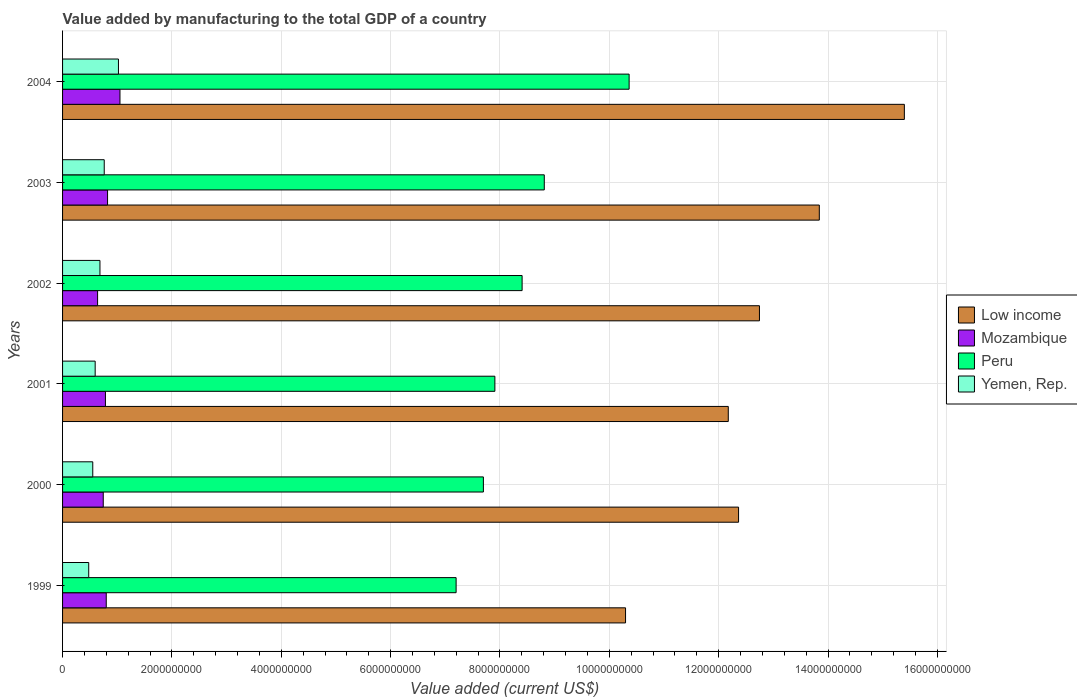How many different coloured bars are there?
Your answer should be compact. 4. Are the number of bars on each tick of the Y-axis equal?
Your response must be concise. Yes. How many bars are there on the 5th tick from the bottom?
Provide a succinct answer. 4. What is the value added by manufacturing to the total GDP in Yemen, Rep. in 1999?
Give a very brief answer. 4.78e+08. Across all years, what is the maximum value added by manufacturing to the total GDP in Yemen, Rep.?
Your answer should be very brief. 1.02e+09. Across all years, what is the minimum value added by manufacturing to the total GDP in Yemen, Rep.?
Provide a succinct answer. 4.78e+08. In which year was the value added by manufacturing to the total GDP in Yemen, Rep. maximum?
Provide a short and direct response. 2004. What is the total value added by manufacturing to the total GDP in Low income in the graph?
Your response must be concise. 7.68e+1. What is the difference between the value added by manufacturing to the total GDP in Mozambique in 2001 and that in 2002?
Provide a succinct answer. 1.43e+08. What is the difference between the value added by manufacturing to the total GDP in Yemen, Rep. in 2004 and the value added by manufacturing to the total GDP in Peru in 2002?
Your answer should be compact. -7.38e+09. What is the average value added by manufacturing to the total GDP in Low income per year?
Provide a succinct answer. 1.28e+1. In the year 2003, what is the difference between the value added by manufacturing to the total GDP in Low income and value added by manufacturing to the total GDP in Yemen, Rep.?
Offer a very short reply. 1.31e+1. What is the ratio of the value added by manufacturing to the total GDP in Yemen, Rep. in 2001 to that in 2002?
Your answer should be compact. 0.87. Is the value added by manufacturing to the total GDP in Yemen, Rep. in 2000 less than that in 2001?
Offer a very short reply. Yes. What is the difference between the highest and the second highest value added by manufacturing to the total GDP in Low income?
Provide a succinct answer. 1.56e+09. What is the difference between the highest and the lowest value added by manufacturing to the total GDP in Low income?
Keep it short and to the point. 5.10e+09. What does the 3rd bar from the top in 2003 represents?
Your response must be concise. Mozambique. What does the 4th bar from the bottom in 2004 represents?
Provide a short and direct response. Yemen, Rep. Is it the case that in every year, the sum of the value added by manufacturing to the total GDP in Mozambique and value added by manufacturing to the total GDP in Low income is greater than the value added by manufacturing to the total GDP in Peru?
Your response must be concise. Yes. How many bars are there?
Provide a short and direct response. 24. Are all the bars in the graph horizontal?
Ensure brevity in your answer.  Yes. How are the legend labels stacked?
Offer a very short reply. Vertical. What is the title of the graph?
Offer a very short reply. Value added by manufacturing to the total GDP of a country. What is the label or title of the X-axis?
Provide a short and direct response. Value added (current US$). What is the label or title of the Y-axis?
Ensure brevity in your answer.  Years. What is the Value added (current US$) of Low income in 1999?
Provide a succinct answer. 1.03e+1. What is the Value added (current US$) of Mozambique in 1999?
Ensure brevity in your answer.  7.99e+08. What is the Value added (current US$) in Peru in 1999?
Ensure brevity in your answer.  7.20e+09. What is the Value added (current US$) of Yemen, Rep. in 1999?
Your answer should be very brief. 4.78e+08. What is the Value added (current US$) in Low income in 2000?
Your answer should be very brief. 1.24e+1. What is the Value added (current US$) of Mozambique in 2000?
Provide a succinct answer. 7.44e+08. What is the Value added (current US$) of Peru in 2000?
Keep it short and to the point. 7.70e+09. What is the Value added (current US$) in Yemen, Rep. in 2000?
Your answer should be very brief. 5.52e+08. What is the Value added (current US$) of Low income in 2001?
Make the answer very short. 1.22e+1. What is the Value added (current US$) of Mozambique in 2001?
Make the answer very short. 7.84e+08. What is the Value added (current US$) in Peru in 2001?
Your answer should be compact. 7.91e+09. What is the Value added (current US$) of Yemen, Rep. in 2001?
Offer a terse response. 5.96e+08. What is the Value added (current US$) of Low income in 2002?
Give a very brief answer. 1.27e+1. What is the Value added (current US$) in Mozambique in 2002?
Provide a short and direct response. 6.41e+08. What is the Value added (current US$) of Peru in 2002?
Your response must be concise. 8.40e+09. What is the Value added (current US$) of Yemen, Rep. in 2002?
Your answer should be very brief. 6.84e+08. What is the Value added (current US$) in Low income in 2003?
Keep it short and to the point. 1.38e+1. What is the Value added (current US$) of Mozambique in 2003?
Ensure brevity in your answer.  8.23e+08. What is the Value added (current US$) in Peru in 2003?
Make the answer very short. 8.81e+09. What is the Value added (current US$) in Yemen, Rep. in 2003?
Provide a succinct answer. 7.62e+08. What is the Value added (current US$) in Low income in 2004?
Make the answer very short. 1.54e+1. What is the Value added (current US$) in Mozambique in 2004?
Offer a terse response. 1.05e+09. What is the Value added (current US$) in Peru in 2004?
Your answer should be very brief. 1.04e+1. What is the Value added (current US$) in Yemen, Rep. in 2004?
Provide a succinct answer. 1.02e+09. Across all years, what is the maximum Value added (current US$) in Low income?
Offer a terse response. 1.54e+1. Across all years, what is the maximum Value added (current US$) in Mozambique?
Provide a short and direct response. 1.05e+09. Across all years, what is the maximum Value added (current US$) of Peru?
Your response must be concise. 1.04e+1. Across all years, what is the maximum Value added (current US$) in Yemen, Rep.?
Offer a terse response. 1.02e+09. Across all years, what is the minimum Value added (current US$) of Low income?
Your answer should be compact. 1.03e+1. Across all years, what is the minimum Value added (current US$) in Mozambique?
Make the answer very short. 6.41e+08. Across all years, what is the minimum Value added (current US$) of Peru?
Your response must be concise. 7.20e+09. Across all years, what is the minimum Value added (current US$) in Yemen, Rep.?
Ensure brevity in your answer.  4.78e+08. What is the total Value added (current US$) in Low income in the graph?
Your answer should be compact. 7.68e+1. What is the total Value added (current US$) in Mozambique in the graph?
Your response must be concise. 4.84e+09. What is the total Value added (current US$) in Peru in the graph?
Provide a succinct answer. 5.04e+1. What is the total Value added (current US$) of Yemen, Rep. in the graph?
Give a very brief answer. 4.09e+09. What is the difference between the Value added (current US$) of Low income in 1999 and that in 2000?
Keep it short and to the point. -2.07e+09. What is the difference between the Value added (current US$) of Mozambique in 1999 and that in 2000?
Your answer should be compact. 5.49e+07. What is the difference between the Value added (current US$) in Peru in 1999 and that in 2000?
Offer a very short reply. -4.99e+08. What is the difference between the Value added (current US$) in Yemen, Rep. in 1999 and that in 2000?
Your answer should be very brief. -7.40e+07. What is the difference between the Value added (current US$) of Low income in 1999 and that in 2001?
Provide a short and direct response. -1.88e+09. What is the difference between the Value added (current US$) of Mozambique in 1999 and that in 2001?
Keep it short and to the point. 1.49e+07. What is the difference between the Value added (current US$) in Peru in 1999 and that in 2001?
Ensure brevity in your answer.  -7.09e+08. What is the difference between the Value added (current US$) in Yemen, Rep. in 1999 and that in 2001?
Provide a short and direct response. -1.18e+08. What is the difference between the Value added (current US$) in Low income in 1999 and that in 2002?
Your answer should be compact. -2.45e+09. What is the difference between the Value added (current US$) of Mozambique in 1999 and that in 2002?
Give a very brief answer. 1.58e+08. What is the difference between the Value added (current US$) of Peru in 1999 and that in 2002?
Offer a very short reply. -1.21e+09. What is the difference between the Value added (current US$) of Yemen, Rep. in 1999 and that in 2002?
Provide a succinct answer. -2.05e+08. What is the difference between the Value added (current US$) of Low income in 1999 and that in 2003?
Provide a succinct answer. -3.54e+09. What is the difference between the Value added (current US$) in Mozambique in 1999 and that in 2003?
Your answer should be compact. -2.40e+07. What is the difference between the Value added (current US$) of Peru in 1999 and that in 2003?
Offer a terse response. -1.61e+09. What is the difference between the Value added (current US$) of Yemen, Rep. in 1999 and that in 2003?
Offer a very short reply. -2.84e+08. What is the difference between the Value added (current US$) in Low income in 1999 and that in 2004?
Your answer should be compact. -5.10e+09. What is the difference between the Value added (current US$) in Mozambique in 1999 and that in 2004?
Provide a short and direct response. -2.51e+08. What is the difference between the Value added (current US$) of Peru in 1999 and that in 2004?
Keep it short and to the point. -3.16e+09. What is the difference between the Value added (current US$) of Yemen, Rep. in 1999 and that in 2004?
Keep it short and to the point. -5.44e+08. What is the difference between the Value added (current US$) in Low income in 2000 and that in 2001?
Offer a terse response. 1.88e+08. What is the difference between the Value added (current US$) of Mozambique in 2000 and that in 2001?
Keep it short and to the point. -4.00e+07. What is the difference between the Value added (current US$) of Peru in 2000 and that in 2001?
Ensure brevity in your answer.  -2.10e+08. What is the difference between the Value added (current US$) in Yemen, Rep. in 2000 and that in 2001?
Ensure brevity in your answer.  -4.41e+07. What is the difference between the Value added (current US$) of Low income in 2000 and that in 2002?
Offer a terse response. -3.82e+08. What is the difference between the Value added (current US$) in Mozambique in 2000 and that in 2002?
Ensure brevity in your answer.  1.03e+08. What is the difference between the Value added (current US$) of Peru in 2000 and that in 2002?
Your answer should be compact. -7.08e+08. What is the difference between the Value added (current US$) of Yemen, Rep. in 2000 and that in 2002?
Provide a succinct answer. -1.31e+08. What is the difference between the Value added (current US$) of Low income in 2000 and that in 2003?
Your answer should be compact. -1.48e+09. What is the difference between the Value added (current US$) of Mozambique in 2000 and that in 2003?
Your answer should be very brief. -7.89e+07. What is the difference between the Value added (current US$) of Peru in 2000 and that in 2003?
Give a very brief answer. -1.11e+09. What is the difference between the Value added (current US$) in Yemen, Rep. in 2000 and that in 2003?
Offer a terse response. -2.10e+08. What is the difference between the Value added (current US$) of Low income in 2000 and that in 2004?
Offer a terse response. -3.03e+09. What is the difference between the Value added (current US$) of Mozambique in 2000 and that in 2004?
Offer a terse response. -3.06e+08. What is the difference between the Value added (current US$) of Peru in 2000 and that in 2004?
Offer a terse response. -2.67e+09. What is the difference between the Value added (current US$) of Yemen, Rep. in 2000 and that in 2004?
Ensure brevity in your answer.  -4.70e+08. What is the difference between the Value added (current US$) in Low income in 2001 and that in 2002?
Keep it short and to the point. -5.70e+08. What is the difference between the Value added (current US$) in Mozambique in 2001 and that in 2002?
Offer a terse response. 1.43e+08. What is the difference between the Value added (current US$) of Peru in 2001 and that in 2002?
Your answer should be very brief. -4.98e+08. What is the difference between the Value added (current US$) of Yemen, Rep. in 2001 and that in 2002?
Offer a terse response. -8.73e+07. What is the difference between the Value added (current US$) in Low income in 2001 and that in 2003?
Provide a short and direct response. -1.66e+09. What is the difference between the Value added (current US$) in Mozambique in 2001 and that in 2003?
Provide a short and direct response. -3.89e+07. What is the difference between the Value added (current US$) in Peru in 2001 and that in 2003?
Keep it short and to the point. -9.04e+08. What is the difference between the Value added (current US$) in Yemen, Rep. in 2001 and that in 2003?
Your response must be concise. -1.66e+08. What is the difference between the Value added (current US$) in Low income in 2001 and that in 2004?
Your response must be concise. -3.22e+09. What is the difference between the Value added (current US$) in Mozambique in 2001 and that in 2004?
Offer a terse response. -2.66e+08. What is the difference between the Value added (current US$) in Peru in 2001 and that in 2004?
Offer a very short reply. -2.46e+09. What is the difference between the Value added (current US$) of Yemen, Rep. in 2001 and that in 2004?
Provide a short and direct response. -4.26e+08. What is the difference between the Value added (current US$) in Low income in 2002 and that in 2003?
Provide a short and direct response. -1.09e+09. What is the difference between the Value added (current US$) of Mozambique in 2002 and that in 2003?
Your answer should be compact. -1.82e+08. What is the difference between the Value added (current US$) in Peru in 2002 and that in 2003?
Keep it short and to the point. -4.06e+08. What is the difference between the Value added (current US$) in Yemen, Rep. in 2002 and that in 2003?
Your answer should be compact. -7.83e+07. What is the difference between the Value added (current US$) of Low income in 2002 and that in 2004?
Give a very brief answer. -2.65e+09. What is the difference between the Value added (current US$) in Mozambique in 2002 and that in 2004?
Ensure brevity in your answer.  -4.09e+08. What is the difference between the Value added (current US$) of Peru in 2002 and that in 2004?
Give a very brief answer. -1.96e+09. What is the difference between the Value added (current US$) of Yemen, Rep. in 2002 and that in 2004?
Your answer should be very brief. -3.38e+08. What is the difference between the Value added (current US$) of Low income in 2003 and that in 2004?
Keep it short and to the point. -1.56e+09. What is the difference between the Value added (current US$) in Mozambique in 2003 and that in 2004?
Keep it short and to the point. -2.27e+08. What is the difference between the Value added (current US$) of Peru in 2003 and that in 2004?
Keep it short and to the point. -1.55e+09. What is the difference between the Value added (current US$) of Yemen, Rep. in 2003 and that in 2004?
Provide a succinct answer. -2.60e+08. What is the difference between the Value added (current US$) of Low income in 1999 and the Value added (current US$) of Mozambique in 2000?
Offer a terse response. 9.55e+09. What is the difference between the Value added (current US$) of Low income in 1999 and the Value added (current US$) of Peru in 2000?
Your response must be concise. 2.60e+09. What is the difference between the Value added (current US$) in Low income in 1999 and the Value added (current US$) in Yemen, Rep. in 2000?
Your answer should be very brief. 9.74e+09. What is the difference between the Value added (current US$) of Mozambique in 1999 and the Value added (current US$) of Peru in 2000?
Provide a succinct answer. -6.90e+09. What is the difference between the Value added (current US$) in Mozambique in 1999 and the Value added (current US$) in Yemen, Rep. in 2000?
Keep it short and to the point. 2.47e+08. What is the difference between the Value added (current US$) in Peru in 1999 and the Value added (current US$) in Yemen, Rep. in 2000?
Ensure brevity in your answer.  6.65e+09. What is the difference between the Value added (current US$) of Low income in 1999 and the Value added (current US$) of Mozambique in 2001?
Offer a very short reply. 9.51e+09. What is the difference between the Value added (current US$) of Low income in 1999 and the Value added (current US$) of Peru in 2001?
Provide a succinct answer. 2.39e+09. What is the difference between the Value added (current US$) in Low income in 1999 and the Value added (current US$) in Yemen, Rep. in 2001?
Keep it short and to the point. 9.70e+09. What is the difference between the Value added (current US$) in Mozambique in 1999 and the Value added (current US$) in Peru in 2001?
Keep it short and to the point. -7.11e+09. What is the difference between the Value added (current US$) of Mozambique in 1999 and the Value added (current US$) of Yemen, Rep. in 2001?
Ensure brevity in your answer.  2.03e+08. What is the difference between the Value added (current US$) of Peru in 1999 and the Value added (current US$) of Yemen, Rep. in 2001?
Provide a succinct answer. 6.60e+09. What is the difference between the Value added (current US$) of Low income in 1999 and the Value added (current US$) of Mozambique in 2002?
Your answer should be compact. 9.66e+09. What is the difference between the Value added (current US$) in Low income in 1999 and the Value added (current US$) in Peru in 2002?
Provide a short and direct response. 1.89e+09. What is the difference between the Value added (current US$) in Low income in 1999 and the Value added (current US$) in Yemen, Rep. in 2002?
Your answer should be very brief. 9.61e+09. What is the difference between the Value added (current US$) in Mozambique in 1999 and the Value added (current US$) in Peru in 2002?
Give a very brief answer. -7.61e+09. What is the difference between the Value added (current US$) of Mozambique in 1999 and the Value added (current US$) of Yemen, Rep. in 2002?
Give a very brief answer. 1.15e+08. What is the difference between the Value added (current US$) in Peru in 1999 and the Value added (current US$) in Yemen, Rep. in 2002?
Make the answer very short. 6.51e+09. What is the difference between the Value added (current US$) of Low income in 1999 and the Value added (current US$) of Mozambique in 2003?
Offer a very short reply. 9.47e+09. What is the difference between the Value added (current US$) in Low income in 1999 and the Value added (current US$) in Peru in 2003?
Make the answer very short. 1.49e+09. What is the difference between the Value added (current US$) in Low income in 1999 and the Value added (current US$) in Yemen, Rep. in 2003?
Keep it short and to the point. 9.53e+09. What is the difference between the Value added (current US$) in Mozambique in 1999 and the Value added (current US$) in Peru in 2003?
Your answer should be compact. -8.01e+09. What is the difference between the Value added (current US$) of Mozambique in 1999 and the Value added (current US$) of Yemen, Rep. in 2003?
Provide a short and direct response. 3.70e+07. What is the difference between the Value added (current US$) in Peru in 1999 and the Value added (current US$) in Yemen, Rep. in 2003?
Give a very brief answer. 6.44e+09. What is the difference between the Value added (current US$) in Low income in 1999 and the Value added (current US$) in Mozambique in 2004?
Your answer should be very brief. 9.25e+09. What is the difference between the Value added (current US$) in Low income in 1999 and the Value added (current US$) in Peru in 2004?
Your response must be concise. -6.55e+07. What is the difference between the Value added (current US$) of Low income in 1999 and the Value added (current US$) of Yemen, Rep. in 2004?
Keep it short and to the point. 9.27e+09. What is the difference between the Value added (current US$) in Mozambique in 1999 and the Value added (current US$) in Peru in 2004?
Provide a short and direct response. -9.56e+09. What is the difference between the Value added (current US$) in Mozambique in 1999 and the Value added (current US$) in Yemen, Rep. in 2004?
Give a very brief answer. -2.23e+08. What is the difference between the Value added (current US$) of Peru in 1999 and the Value added (current US$) of Yemen, Rep. in 2004?
Your answer should be very brief. 6.18e+09. What is the difference between the Value added (current US$) of Low income in 2000 and the Value added (current US$) of Mozambique in 2001?
Your response must be concise. 1.16e+1. What is the difference between the Value added (current US$) of Low income in 2000 and the Value added (current US$) of Peru in 2001?
Your response must be concise. 4.46e+09. What is the difference between the Value added (current US$) in Low income in 2000 and the Value added (current US$) in Yemen, Rep. in 2001?
Keep it short and to the point. 1.18e+1. What is the difference between the Value added (current US$) in Mozambique in 2000 and the Value added (current US$) in Peru in 2001?
Provide a short and direct response. -7.16e+09. What is the difference between the Value added (current US$) of Mozambique in 2000 and the Value added (current US$) of Yemen, Rep. in 2001?
Ensure brevity in your answer.  1.48e+08. What is the difference between the Value added (current US$) in Peru in 2000 and the Value added (current US$) in Yemen, Rep. in 2001?
Provide a short and direct response. 7.10e+09. What is the difference between the Value added (current US$) in Low income in 2000 and the Value added (current US$) in Mozambique in 2002?
Ensure brevity in your answer.  1.17e+1. What is the difference between the Value added (current US$) in Low income in 2000 and the Value added (current US$) in Peru in 2002?
Provide a succinct answer. 3.96e+09. What is the difference between the Value added (current US$) in Low income in 2000 and the Value added (current US$) in Yemen, Rep. in 2002?
Offer a very short reply. 1.17e+1. What is the difference between the Value added (current US$) of Mozambique in 2000 and the Value added (current US$) of Peru in 2002?
Your answer should be compact. -7.66e+09. What is the difference between the Value added (current US$) in Mozambique in 2000 and the Value added (current US$) in Yemen, Rep. in 2002?
Your answer should be very brief. 6.04e+07. What is the difference between the Value added (current US$) in Peru in 2000 and the Value added (current US$) in Yemen, Rep. in 2002?
Ensure brevity in your answer.  7.01e+09. What is the difference between the Value added (current US$) of Low income in 2000 and the Value added (current US$) of Mozambique in 2003?
Keep it short and to the point. 1.15e+1. What is the difference between the Value added (current US$) of Low income in 2000 and the Value added (current US$) of Peru in 2003?
Your answer should be compact. 3.55e+09. What is the difference between the Value added (current US$) of Low income in 2000 and the Value added (current US$) of Yemen, Rep. in 2003?
Your answer should be very brief. 1.16e+1. What is the difference between the Value added (current US$) in Mozambique in 2000 and the Value added (current US$) in Peru in 2003?
Your response must be concise. -8.07e+09. What is the difference between the Value added (current US$) in Mozambique in 2000 and the Value added (current US$) in Yemen, Rep. in 2003?
Your response must be concise. -1.79e+07. What is the difference between the Value added (current US$) in Peru in 2000 and the Value added (current US$) in Yemen, Rep. in 2003?
Your answer should be compact. 6.93e+09. What is the difference between the Value added (current US$) in Low income in 2000 and the Value added (current US$) in Mozambique in 2004?
Provide a short and direct response. 1.13e+1. What is the difference between the Value added (current US$) in Low income in 2000 and the Value added (current US$) in Peru in 2004?
Your answer should be compact. 2.00e+09. What is the difference between the Value added (current US$) in Low income in 2000 and the Value added (current US$) in Yemen, Rep. in 2004?
Make the answer very short. 1.13e+1. What is the difference between the Value added (current US$) in Mozambique in 2000 and the Value added (current US$) in Peru in 2004?
Your answer should be compact. -9.62e+09. What is the difference between the Value added (current US$) of Mozambique in 2000 and the Value added (current US$) of Yemen, Rep. in 2004?
Make the answer very short. -2.78e+08. What is the difference between the Value added (current US$) of Peru in 2000 and the Value added (current US$) of Yemen, Rep. in 2004?
Your response must be concise. 6.67e+09. What is the difference between the Value added (current US$) in Low income in 2001 and the Value added (current US$) in Mozambique in 2002?
Keep it short and to the point. 1.15e+1. What is the difference between the Value added (current US$) of Low income in 2001 and the Value added (current US$) of Peru in 2002?
Offer a very short reply. 3.77e+09. What is the difference between the Value added (current US$) in Low income in 2001 and the Value added (current US$) in Yemen, Rep. in 2002?
Your answer should be very brief. 1.15e+1. What is the difference between the Value added (current US$) of Mozambique in 2001 and the Value added (current US$) of Peru in 2002?
Offer a terse response. -7.62e+09. What is the difference between the Value added (current US$) in Mozambique in 2001 and the Value added (current US$) in Yemen, Rep. in 2002?
Your response must be concise. 1.00e+08. What is the difference between the Value added (current US$) of Peru in 2001 and the Value added (current US$) of Yemen, Rep. in 2002?
Keep it short and to the point. 7.22e+09. What is the difference between the Value added (current US$) in Low income in 2001 and the Value added (current US$) in Mozambique in 2003?
Your response must be concise. 1.14e+1. What is the difference between the Value added (current US$) of Low income in 2001 and the Value added (current US$) of Peru in 2003?
Provide a succinct answer. 3.37e+09. What is the difference between the Value added (current US$) in Low income in 2001 and the Value added (current US$) in Yemen, Rep. in 2003?
Offer a very short reply. 1.14e+1. What is the difference between the Value added (current US$) in Mozambique in 2001 and the Value added (current US$) in Peru in 2003?
Provide a succinct answer. -8.03e+09. What is the difference between the Value added (current US$) of Mozambique in 2001 and the Value added (current US$) of Yemen, Rep. in 2003?
Provide a succinct answer. 2.21e+07. What is the difference between the Value added (current US$) in Peru in 2001 and the Value added (current US$) in Yemen, Rep. in 2003?
Your response must be concise. 7.14e+09. What is the difference between the Value added (current US$) in Low income in 2001 and the Value added (current US$) in Mozambique in 2004?
Provide a succinct answer. 1.11e+1. What is the difference between the Value added (current US$) in Low income in 2001 and the Value added (current US$) in Peru in 2004?
Provide a short and direct response. 1.81e+09. What is the difference between the Value added (current US$) of Low income in 2001 and the Value added (current US$) of Yemen, Rep. in 2004?
Keep it short and to the point. 1.12e+1. What is the difference between the Value added (current US$) in Mozambique in 2001 and the Value added (current US$) in Peru in 2004?
Your response must be concise. -9.58e+09. What is the difference between the Value added (current US$) in Mozambique in 2001 and the Value added (current US$) in Yemen, Rep. in 2004?
Offer a very short reply. -2.38e+08. What is the difference between the Value added (current US$) in Peru in 2001 and the Value added (current US$) in Yemen, Rep. in 2004?
Give a very brief answer. 6.88e+09. What is the difference between the Value added (current US$) in Low income in 2002 and the Value added (current US$) in Mozambique in 2003?
Offer a very short reply. 1.19e+1. What is the difference between the Value added (current US$) of Low income in 2002 and the Value added (current US$) of Peru in 2003?
Keep it short and to the point. 3.94e+09. What is the difference between the Value added (current US$) in Low income in 2002 and the Value added (current US$) in Yemen, Rep. in 2003?
Your response must be concise. 1.20e+1. What is the difference between the Value added (current US$) in Mozambique in 2002 and the Value added (current US$) in Peru in 2003?
Offer a very short reply. -8.17e+09. What is the difference between the Value added (current US$) of Mozambique in 2002 and the Value added (current US$) of Yemen, Rep. in 2003?
Make the answer very short. -1.21e+08. What is the difference between the Value added (current US$) in Peru in 2002 and the Value added (current US$) in Yemen, Rep. in 2003?
Ensure brevity in your answer.  7.64e+09. What is the difference between the Value added (current US$) of Low income in 2002 and the Value added (current US$) of Mozambique in 2004?
Give a very brief answer. 1.17e+1. What is the difference between the Value added (current US$) of Low income in 2002 and the Value added (current US$) of Peru in 2004?
Your answer should be compact. 2.38e+09. What is the difference between the Value added (current US$) in Low income in 2002 and the Value added (current US$) in Yemen, Rep. in 2004?
Offer a terse response. 1.17e+1. What is the difference between the Value added (current US$) of Mozambique in 2002 and the Value added (current US$) of Peru in 2004?
Ensure brevity in your answer.  -9.72e+09. What is the difference between the Value added (current US$) in Mozambique in 2002 and the Value added (current US$) in Yemen, Rep. in 2004?
Your response must be concise. -3.81e+08. What is the difference between the Value added (current US$) in Peru in 2002 and the Value added (current US$) in Yemen, Rep. in 2004?
Your response must be concise. 7.38e+09. What is the difference between the Value added (current US$) in Low income in 2003 and the Value added (current US$) in Mozambique in 2004?
Offer a very short reply. 1.28e+1. What is the difference between the Value added (current US$) of Low income in 2003 and the Value added (current US$) of Peru in 2004?
Your answer should be compact. 3.48e+09. What is the difference between the Value added (current US$) in Low income in 2003 and the Value added (current US$) in Yemen, Rep. in 2004?
Ensure brevity in your answer.  1.28e+1. What is the difference between the Value added (current US$) of Mozambique in 2003 and the Value added (current US$) of Peru in 2004?
Offer a terse response. -9.54e+09. What is the difference between the Value added (current US$) in Mozambique in 2003 and the Value added (current US$) in Yemen, Rep. in 2004?
Give a very brief answer. -1.99e+08. What is the difference between the Value added (current US$) of Peru in 2003 and the Value added (current US$) of Yemen, Rep. in 2004?
Keep it short and to the point. 7.79e+09. What is the average Value added (current US$) in Low income per year?
Make the answer very short. 1.28e+1. What is the average Value added (current US$) in Mozambique per year?
Give a very brief answer. 8.07e+08. What is the average Value added (current US$) in Peru per year?
Keep it short and to the point. 8.40e+09. What is the average Value added (current US$) in Yemen, Rep. per year?
Make the answer very short. 6.82e+08. In the year 1999, what is the difference between the Value added (current US$) in Low income and Value added (current US$) in Mozambique?
Your answer should be compact. 9.50e+09. In the year 1999, what is the difference between the Value added (current US$) in Low income and Value added (current US$) in Peru?
Ensure brevity in your answer.  3.10e+09. In the year 1999, what is the difference between the Value added (current US$) in Low income and Value added (current US$) in Yemen, Rep.?
Offer a terse response. 9.82e+09. In the year 1999, what is the difference between the Value added (current US$) of Mozambique and Value added (current US$) of Peru?
Make the answer very short. -6.40e+09. In the year 1999, what is the difference between the Value added (current US$) in Mozambique and Value added (current US$) in Yemen, Rep.?
Your answer should be compact. 3.21e+08. In the year 1999, what is the difference between the Value added (current US$) in Peru and Value added (current US$) in Yemen, Rep.?
Make the answer very short. 6.72e+09. In the year 2000, what is the difference between the Value added (current US$) in Low income and Value added (current US$) in Mozambique?
Provide a short and direct response. 1.16e+1. In the year 2000, what is the difference between the Value added (current US$) of Low income and Value added (current US$) of Peru?
Offer a very short reply. 4.67e+09. In the year 2000, what is the difference between the Value added (current US$) in Low income and Value added (current US$) in Yemen, Rep.?
Make the answer very short. 1.18e+1. In the year 2000, what is the difference between the Value added (current US$) in Mozambique and Value added (current US$) in Peru?
Your answer should be compact. -6.95e+09. In the year 2000, what is the difference between the Value added (current US$) in Mozambique and Value added (current US$) in Yemen, Rep.?
Offer a terse response. 1.92e+08. In the year 2000, what is the difference between the Value added (current US$) of Peru and Value added (current US$) of Yemen, Rep.?
Give a very brief answer. 7.14e+09. In the year 2001, what is the difference between the Value added (current US$) of Low income and Value added (current US$) of Mozambique?
Give a very brief answer. 1.14e+1. In the year 2001, what is the difference between the Value added (current US$) of Low income and Value added (current US$) of Peru?
Offer a terse response. 4.27e+09. In the year 2001, what is the difference between the Value added (current US$) in Low income and Value added (current US$) in Yemen, Rep.?
Give a very brief answer. 1.16e+1. In the year 2001, what is the difference between the Value added (current US$) in Mozambique and Value added (current US$) in Peru?
Offer a very short reply. -7.12e+09. In the year 2001, what is the difference between the Value added (current US$) of Mozambique and Value added (current US$) of Yemen, Rep.?
Give a very brief answer. 1.88e+08. In the year 2001, what is the difference between the Value added (current US$) of Peru and Value added (current US$) of Yemen, Rep.?
Your answer should be very brief. 7.31e+09. In the year 2002, what is the difference between the Value added (current US$) in Low income and Value added (current US$) in Mozambique?
Ensure brevity in your answer.  1.21e+1. In the year 2002, what is the difference between the Value added (current US$) in Low income and Value added (current US$) in Peru?
Your answer should be very brief. 4.34e+09. In the year 2002, what is the difference between the Value added (current US$) in Low income and Value added (current US$) in Yemen, Rep.?
Your answer should be very brief. 1.21e+1. In the year 2002, what is the difference between the Value added (current US$) of Mozambique and Value added (current US$) of Peru?
Your response must be concise. -7.76e+09. In the year 2002, what is the difference between the Value added (current US$) of Mozambique and Value added (current US$) of Yemen, Rep.?
Your response must be concise. -4.29e+07. In the year 2002, what is the difference between the Value added (current US$) in Peru and Value added (current US$) in Yemen, Rep.?
Give a very brief answer. 7.72e+09. In the year 2003, what is the difference between the Value added (current US$) in Low income and Value added (current US$) in Mozambique?
Ensure brevity in your answer.  1.30e+1. In the year 2003, what is the difference between the Value added (current US$) of Low income and Value added (current US$) of Peru?
Ensure brevity in your answer.  5.03e+09. In the year 2003, what is the difference between the Value added (current US$) of Low income and Value added (current US$) of Yemen, Rep.?
Your answer should be compact. 1.31e+1. In the year 2003, what is the difference between the Value added (current US$) in Mozambique and Value added (current US$) in Peru?
Your answer should be compact. -7.99e+09. In the year 2003, what is the difference between the Value added (current US$) of Mozambique and Value added (current US$) of Yemen, Rep.?
Your response must be concise. 6.10e+07. In the year 2003, what is the difference between the Value added (current US$) in Peru and Value added (current US$) in Yemen, Rep.?
Provide a succinct answer. 8.05e+09. In the year 2004, what is the difference between the Value added (current US$) in Low income and Value added (current US$) in Mozambique?
Your answer should be very brief. 1.43e+1. In the year 2004, what is the difference between the Value added (current US$) of Low income and Value added (current US$) of Peru?
Your answer should be very brief. 5.03e+09. In the year 2004, what is the difference between the Value added (current US$) in Low income and Value added (current US$) in Yemen, Rep.?
Give a very brief answer. 1.44e+1. In the year 2004, what is the difference between the Value added (current US$) of Mozambique and Value added (current US$) of Peru?
Your response must be concise. -9.31e+09. In the year 2004, what is the difference between the Value added (current US$) in Mozambique and Value added (current US$) in Yemen, Rep.?
Make the answer very short. 2.77e+07. In the year 2004, what is the difference between the Value added (current US$) in Peru and Value added (current US$) in Yemen, Rep.?
Give a very brief answer. 9.34e+09. What is the ratio of the Value added (current US$) in Low income in 1999 to that in 2000?
Your response must be concise. 0.83. What is the ratio of the Value added (current US$) of Mozambique in 1999 to that in 2000?
Make the answer very short. 1.07. What is the ratio of the Value added (current US$) in Peru in 1999 to that in 2000?
Offer a terse response. 0.94. What is the ratio of the Value added (current US$) in Yemen, Rep. in 1999 to that in 2000?
Provide a succinct answer. 0.87. What is the ratio of the Value added (current US$) of Low income in 1999 to that in 2001?
Give a very brief answer. 0.85. What is the ratio of the Value added (current US$) in Peru in 1999 to that in 2001?
Make the answer very short. 0.91. What is the ratio of the Value added (current US$) in Yemen, Rep. in 1999 to that in 2001?
Offer a terse response. 0.8. What is the ratio of the Value added (current US$) in Low income in 1999 to that in 2002?
Keep it short and to the point. 0.81. What is the ratio of the Value added (current US$) of Mozambique in 1999 to that in 2002?
Provide a succinct answer. 1.25. What is the ratio of the Value added (current US$) of Peru in 1999 to that in 2002?
Keep it short and to the point. 0.86. What is the ratio of the Value added (current US$) of Yemen, Rep. in 1999 to that in 2002?
Offer a very short reply. 0.7. What is the ratio of the Value added (current US$) in Low income in 1999 to that in 2003?
Your response must be concise. 0.74. What is the ratio of the Value added (current US$) in Mozambique in 1999 to that in 2003?
Your answer should be compact. 0.97. What is the ratio of the Value added (current US$) in Peru in 1999 to that in 2003?
Offer a terse response. 0.82. What is the ratio of the Value added (current US$) in Yemen, Rep. in 1999 to that in 2003?
Keep it short and to the point. 0.63. What is the ratio of the Value added (current US$) of Low income in 1999 to that in 2004?
Give a very brief answer. 0.67. What is the ratio of the Value added (current US$) in Mozambique in 1999 to that in 2004?
Provide a succinct answer. 0.76. What is the ratio of the Value added (current US$) in Peru in 1999 to that in 2004?
Your answer should be compact. 0.69. What is the ratio of the Value added (current US$) in Yemen, Rep. in 1999 to that in 2004?
Your answer should be very brief. 0.47. What is the ratio of the Value added (current US$) of Low income in 2000 to that in 2001?
Provide a succinct answer. 1.02. What is the ratio of the Value added (current US$) of Mozambique in 2000 to that in 2001?
Your response must be concise. 0.95. What is the ratio of the Value added (current US$) of Peru in 2000 to that in 2001?
Give a very brief answer. 0.97. What is the ratio of the Value added (current US$) in Yemen, Rep. in 2000 to that in 2001?
Provide a succinct answer. 0.93. What is the ratio of the Value added (current US$) of Mozambique in 2000 to that in 2002?
Provide a succinct answer. 1.16. What is the ratio of the Value added (current US$) of Peru in 2000 to that in 2002?
Provide a short and direct response. 0.92. What is the ratio of the Value added (current US$) in Yemen, Rep. in 2000 to that in 2002?
Give a very brief answer. 0.81. What is the ratio of the Value added (current US$) in Low income in 2000 to that in 2003?
Provide a short and direct response. 0.89. What is the ratio of the Value added (current US$) of Mozambique in 2000 to that in 2003?
Your answer should be very brief. 0.9. What is the ratio of the Value added (current US$) in Peru in 2000 to that in 2003?
Your answer should be very brief. 0.87. What is the ratio of the Value added (current US$) of Yemen, Rep. in 2000 to that in 2003?
Offer a terse response. 0.72. What is the ratio of the Value added (current US$) of Low income in 2000 to that in 2004?
Offer a terse response. 0.8. What is the ratio of the Value added (current US$) of Mozambique in 2000 to that in 2004?
Offer a very short reply. 0.71. What is the ratio of the Value added (current US$) in Peru in 2000 to that in 2004?
Your response must be concise. 0.74. What is the ratio of the Value added (current US$) of Yemen, Rep. in 2000 to that in 2004?
Your answer should be very brief. 0.54. What is the ratio of the Value added (current US$) of Low income in 2001 to that in 2002?
Your answer should be very brief. 0.96. What is the ratio of the Value added (current US$) in Mozambique in 2001 to that in 2002?
Ensure brevity in your answer.  1.22. What is the ratio of the Value added (current US$) in Peru in 2001 to that in 2002?
Give a very brief answer. 0.94. What is the ratio of the Value added (current US$) in Yemen, Rep. in 2001 to that in 2002?
Your response must be concise. 0.87. What is the ratio of the Value added (current US$) of Low income in 2001 to that in 2003?
Your response must be concise. 0.88. What is the ratio of the Value added (current US$) in Mozambique in 2001 to that in 2003?
Offer a terse response. 0.95. What is the ratio of the Value added (current US$) in Peru in 2001 to that in 2003?
Your answer should be very brief. 0.9. What is the ratio of the Value added (current US$) of Yemen, Rep. in 2001 to that in 2003?
Provide a short and direct response. 0.78. What is the ratio of the Value added (current US$) in Low income in 2001 to that in 2004?
Ensure brevity in your answer.  0.79. What is the ratio of the Value added (current US$) in Mozambique in 2001 to that in 2004?
Give a very brief answer. 0.75. What is the ratio of the Value added (current US$) in Peru in 2001 to that in 2004?
Your answer should be very brief. 0.76. What is the ratio of the Value added (current US$) of Yemen, Rep. in 2001 to that in 2004?
Your response must be concise. 0.58. What is the ratio of the Value added (current US$) of Low income in 2002 to that in 2003?
Provide a short and direct response. 0.92. What is the ratio of the Value added (current US$) in Mozambique in 2002 to that in 2003?
Give a very brief answer. 0.78. What is the ratio of the Value added (current US$) of Peru in 2002 to that in 2003?
Your answer should be compact. 0.95. What is the ratio of the Value added (current US$) of Yemen, Rep. in 2002 to that in 2003?
Your response must be concise. 0.9. What is the ratio of the Value added (current US$) of Low income in 2002 to that in 2004?
Your answer should be very brief. 0.83. What is the ratio of the Value added (current US$) of Mozambique in 2002 to that in 2004?
Make the answer very short. 0.61. What is the ratio of the Value added (current US$) in Peru in 2002 to that in 2004?
Ensure brevity in your answer.  0.81. What is the ratio of the Value added (current US$) of Yemen, Rep. in 2002 to that in 2004?
Make the answer very short. 0.67. What is the ratio of the Value added (current US$) of Low income in 2003 to that in 2004?
Provide a succinct answer. 0.9. What is the ratio of the Value added (current US$) in Mozambique in 2003 to that in 2004?
Your answer should be compact. 0.78. What is the ratio of the Value added (current US$) in Peru in 2003 to that in 2004?
Offer a terse response. 0.85. What is the ratio of the Value added (current US$) of Yemen, Rep. in 2003 to that in 2004?
Your answer should be compact. 0.75. What is the difference between the highest and the second highest Value added (current US$) of Low income?
Ensure brevity in your answer.  1.56e+09. What is the difference between the highest and the second highest Value added (current US$) of Mozambique?
Ensure brevity in your answer.  2.27e+08. What is the difference between the highest and the second highest Value added (current US$) of Peru?
Offer a terse response. 1.55e+09. What is the difference between the highest and the second highest Value added (current US$) in Yemen, Rep.?
Ensure brevity in your answer.  2.60e+08. What is the difference between the highest and the lowest Value added (current US$) of Low income?
Your response must be concise. 5.10e+09. What is the difference between the highest and the lowest Value added (current US$) of Mozambique?
Your answer should be very brief. 4.09e+08. What is the difference between the highest and the lowest Value added (current US$) in Peru?
Offer a terse response. 3.16e+09. What is the difference between the highest and the lowest Value added (current US$) of Yemen, Rep.?
Offer a terse response. 5.44e+08. 